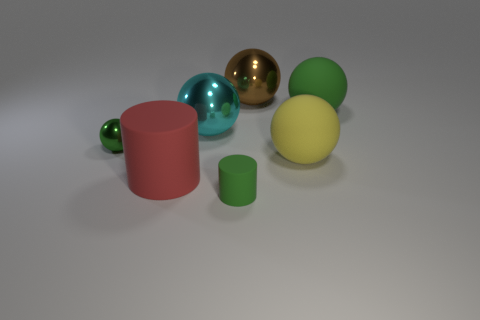Subtract 1 balls. How many balls are left? 4 Subtract all green metal spheres. How many spheres are left? 4 Subtract all brown balls. How many balls are left? 4 Subtract all red spheres. Subtract all gray blocks. How many spheres are left? 5 Add 1 green rubber things. How many objects exist? 8 Subtract all balls. How many objects are left? 2 Subtract all large brown metallic spheres. Subtract all tiny yellow rubber things. How many objects are left? 6 Add 6 metal spheres. How many metal spheres are left? 9 Add 7 big yellow things. How many big yellow things exist? 8 Subtract 0 yellow blocks. How many objects are left? 7 